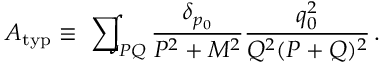Convert formula to latex. <formula><loc_0><loc_0><loc_500><loc_500>A _ { t y p } \equiv \sum \, \int _ { P Q } { \frac { \delta _ { p _ { 0 } } } { P ^ { 2 } + M ^ { 2 } } } { \frac { q _ { 0 } ^ { 2 } } { Q ^ { 2 } ( P + Q ) ^ { 2 } } } \, .</formula> 